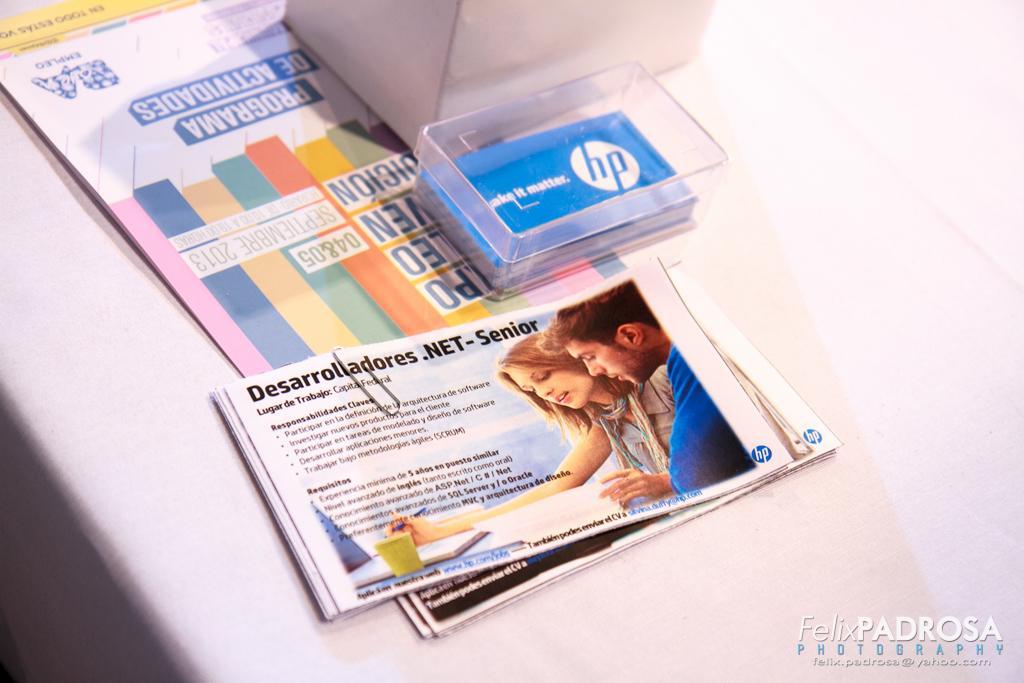Please provide a concise description of this image. In this image there are cards in the box, papers, pamphlets with a paper clip and a box on the table , and there is a watermark on the image. 